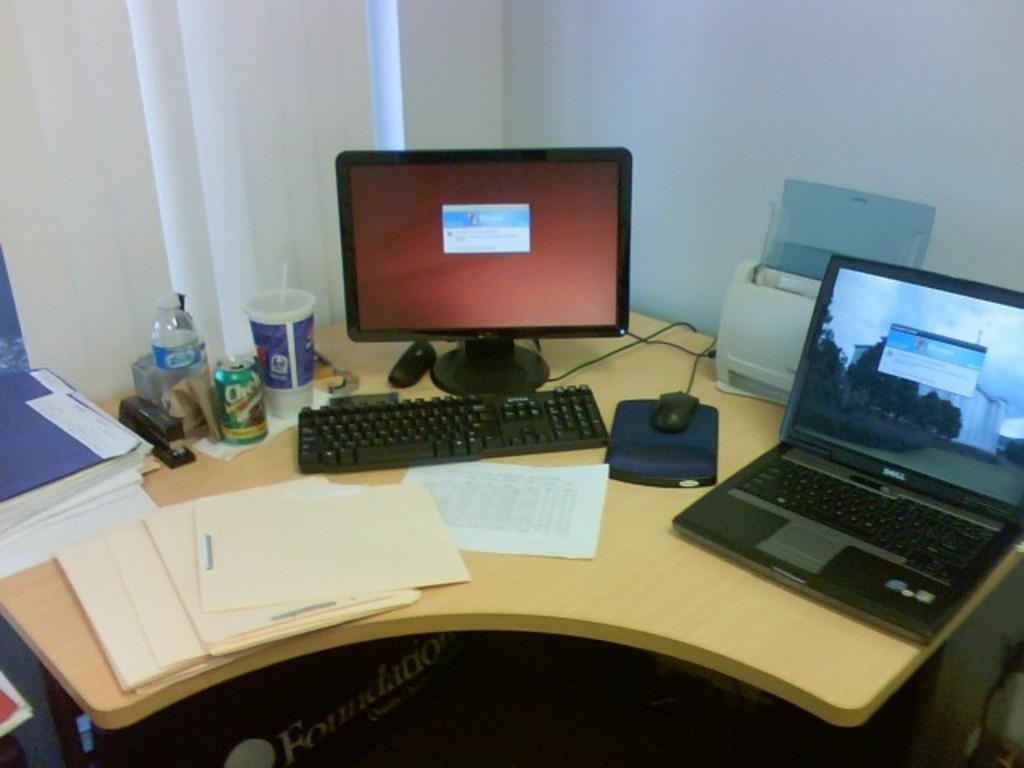What type of furniture is present in the image? There is a table in the image. What is covering the table in the image? The table has covers on it. What type of items can be seen on the table? The table has files, papers, a water bottle, a stapler, a tin, a cup, a computer, a laptop, and a printer on it. Can you describe the window treatment in the image? There is a window blind in the top left corner of the image. How many roses are on the table in the image? There are no roses present in the image. What type of nose can be seen on the zebra in the image? There is no zebra present in the image, and therefore no nose can be seen. 